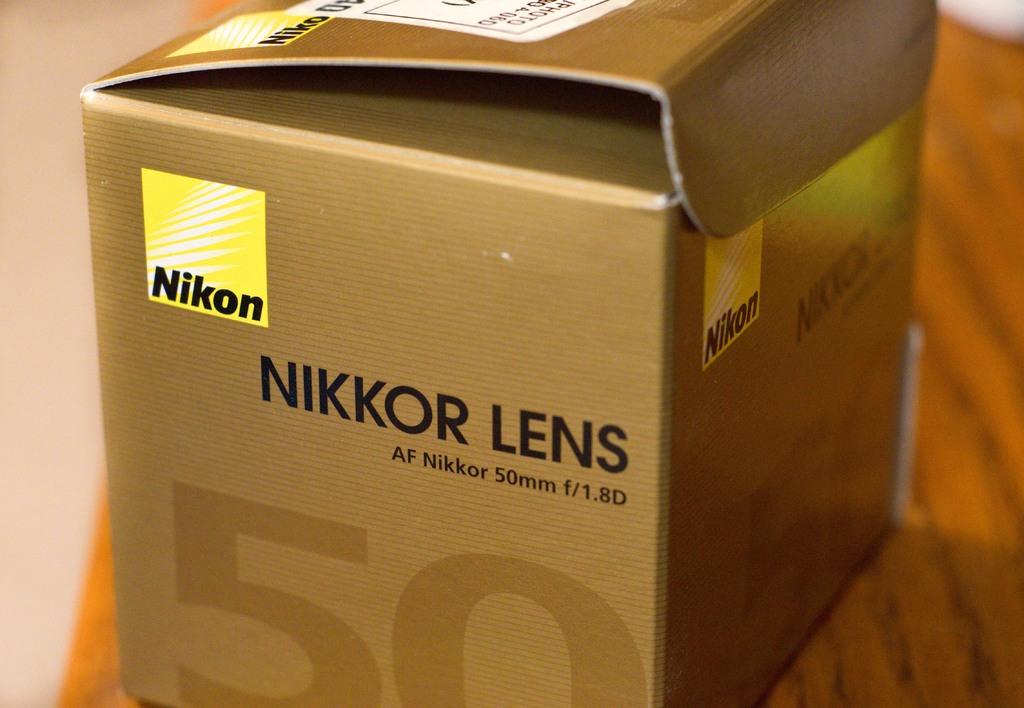What company made this lens?
Provide a succinct answer. Nikon. How many millimeters does it say?
Keep it short and to the point. 50. 